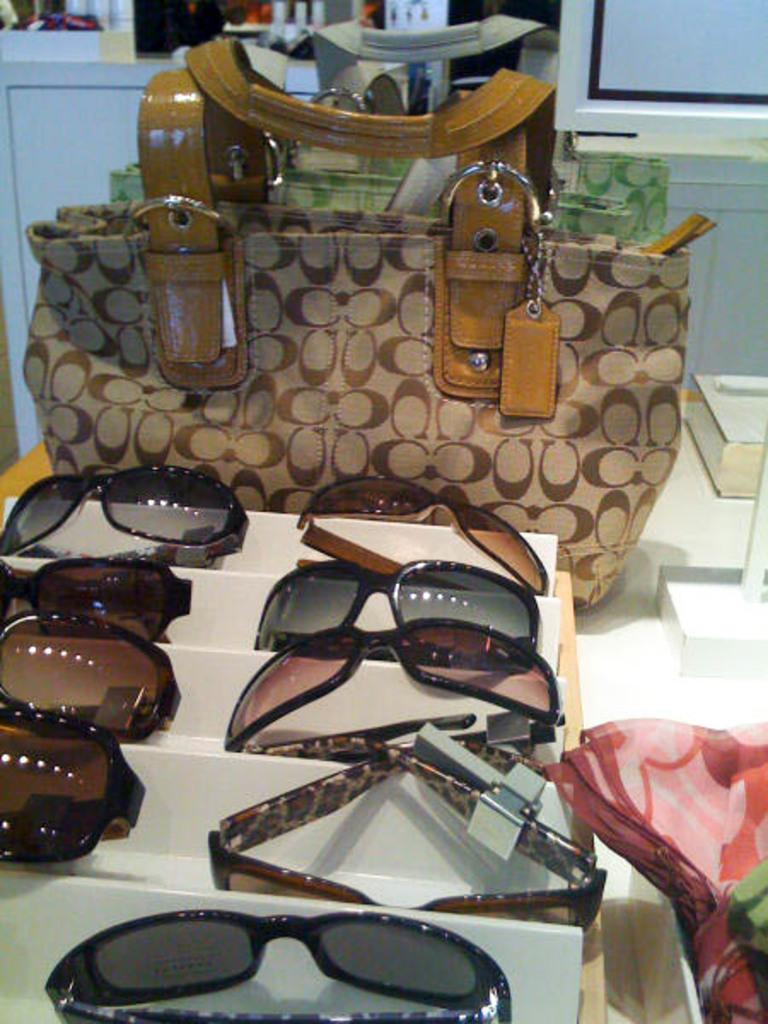What piece of furniture is visible in the image? There is a table in the image. What is placed on the table? There is a bag, a pair of spectacles, and a piece of cloth on the table. What can be seen in the background of the image? There is a cupboard in the background of the image. Can you tell me how many boys are playing on the coast in the image? There is no coast or boys present in the image; it features a table with various objects on it and a cupboard in the background. 